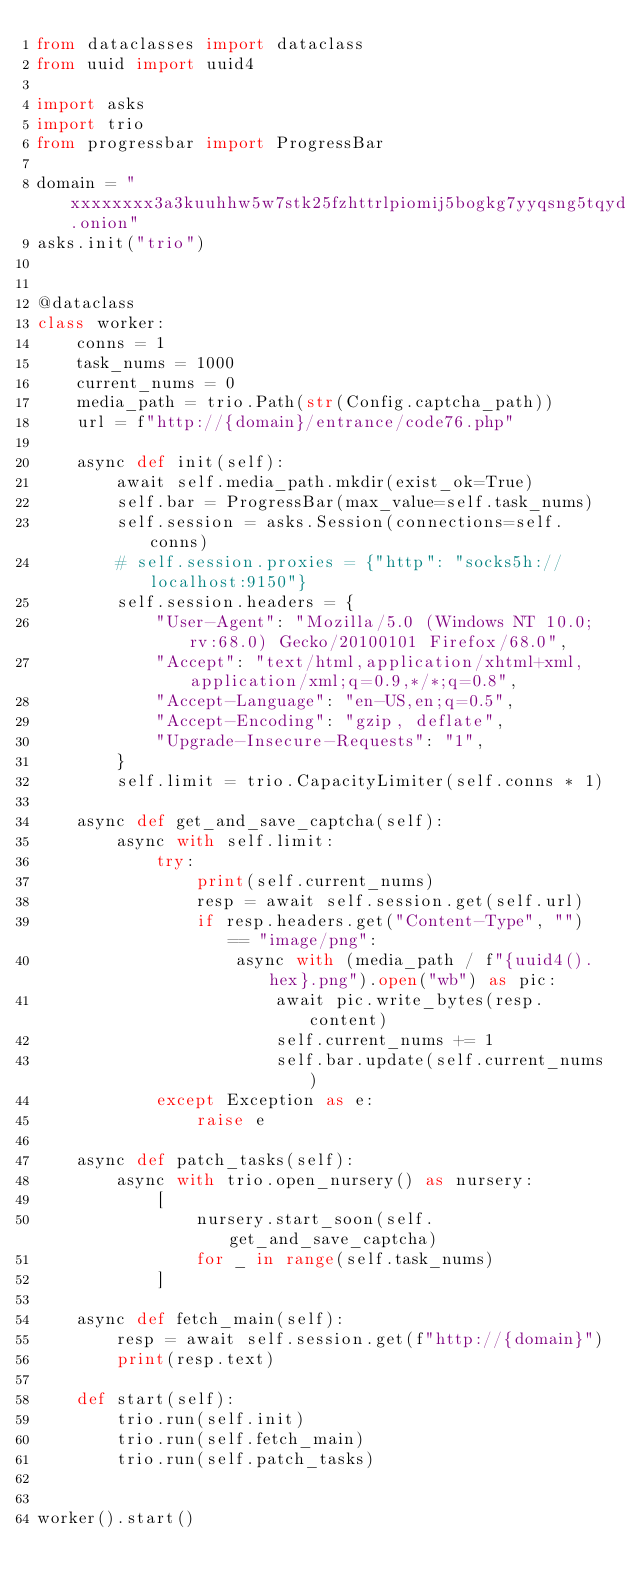<code> <loc_0><loc_0><loc_500><loc_500><_Python_>from dataclasses import dataclass
from uuid import uuid4

import asks
import trio
from progressbar import ProgressBar

domain = "xxxxxxxx3a3kuuhhw5w7stk25fzhttrlpiomij5bogkg7yyqsng5tqyd.onion"
asks.init("trio")


@dataclass
class worker:
    conns = 1
    task_nums = 1000
    current_nums = 0
    media_path = trio.Path(str(Config.captcha_path))
    url = f"http://{domain}/entrance/code76.php"

    async def init(self):
        await self.media_path.mkdir(exist_ok=True)
        self.bar = ProgressBar(max_value=self.task_nums)
        self.session = asks.Session(connections=self.conns)
        # self.session.proxies = {"http": "socks5h://localhost:9150"}
        self.session.headers = {
            "User-Agent": "Mozilla/5.0 (Windows NT 10.0; rv:68.0) Gecko/20100101 Firefox/68.0",
            "Accept": "text/html,application/xhtml+xml,application/xml;q=0.9,*/*;q=0.8",
            "Accept-Language": "en-US,en;q=0.5",
            "Accept-Encoding": "gzip, deflate",
            "Upgrade-Insecure-Requests": "1",
        }
        self.limit = trio.CapacityLimiter(self.conns * 1)

    async def get_and_save_captcha(self):
        async with self.limit:
            try:
                print(self.current_nums)
                resp = await self.session.get(self.url)
                if resp.headers.get("Content-Type", "") == "image/png":
                    async with (media_path / f"{uuid4().hex}.png").open("wb") as pic:
                        await pic.write_bytes(resp.content)
                        self.current_nums += 1
                        self.bar.update(self.current_nums)
            except Exception as e:
                raise e

    async def patch_tasks(self):
        async with trio.open_nursery() as nursery:
            [
                nursery.start_soon(self.get_and_save_captcha)
                for _ in range(self.task_nums)
            ]

    async def fetch_main(self):
        resp = await self.session.get(f"http://{domain}")
        print(resp.text)

    def start(self):
        trio.run(self.init)
        trio.run(self.fetch_main)
        trio.run(self.patch_tasks)


worker().start()
</code> 